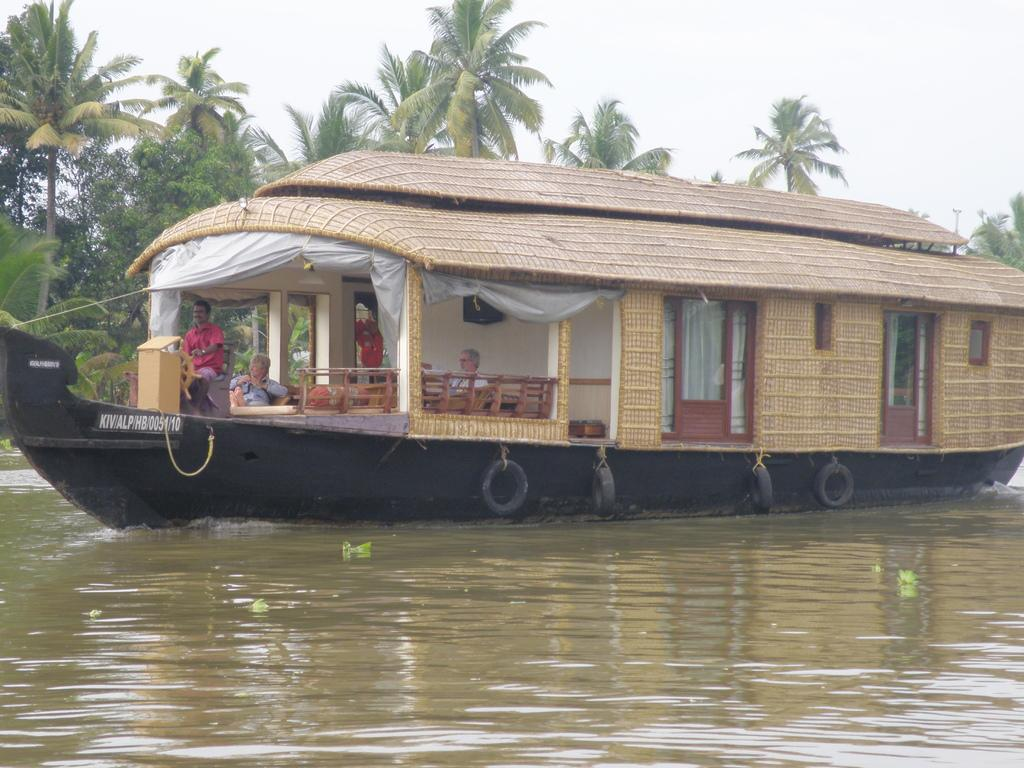What is the main subject in the foreground of the image? There is a boat in the foreground of the image. What is the boat's location in relation to the water? The boat is on the surface of the water. How many people are in the boat? Two persons are sitting in the boat. What can be seen in the background of the image? There are trees and the sky visible in the background of the image. What type of metal is used to make the wine glasses in the image? There are no wine glasses present in the image, so it is not possible to determine the type of metal used to make them. 